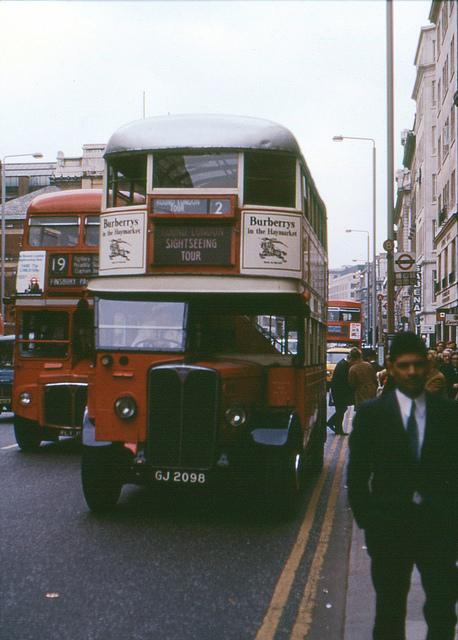Which country were we probably likely to see these old double decker buses? england 